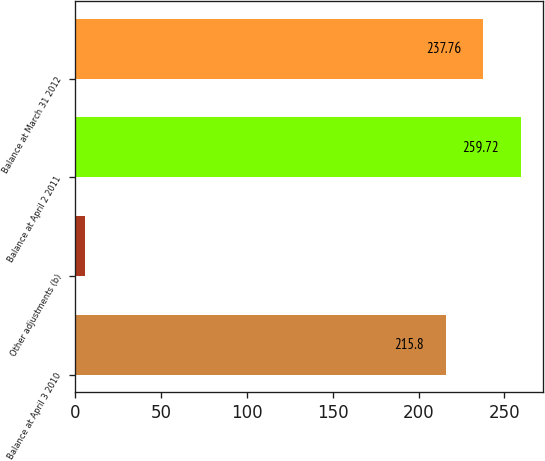Convert chart. <chart><loc_0><loc_0><loc_500><loc_500><bar_chart><fcel>Balance at April 3 2010<fcel>Other adjustments (b)<fcel>Balance at April 2 2011<fcel>Balance at March 31 2012<nl><fcel>215.8<fcel>5.8<fcel>259.72<fcel>237.76<nl></chart> 